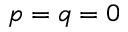Convert formula to latex. <formula><loc_0><loc_0><loc_500><loc_500>p = q = 0</formula> 